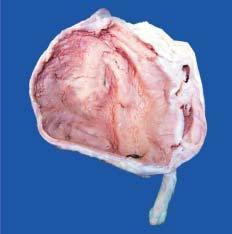does sectioned surface show markedly dilated pelvis and calyces having irregular and ragged inner surface and containing necrotic debris and pus?
Answer the question using a single word or phrase. Yes 